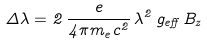Convert formula to latex. <formula><loc_0><loc_0><loc_500><loc_500>\Delta \lambda = 2 \, \frac { e } { 4 \pi m _ { e } c ^ { 2 } } \, \lambda ^ { 2 } \, g _ { e f f } \, B _ { z }</formula> 